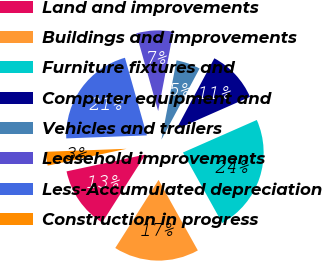Convert chart to OTSL. <chart><loc_0><loc_0><loc_500><loc_500><pie_chart><fcel>Land and improvements<fcel>Buildings and improvements<fcel>Furniture fixtures and<fcel>Computer equipment and<fcel>Vehicles and trailers<fcel>Leasehold improvements<fcel>Less-Accumulated depreciation<fcel>Construction in progress<nl><fcel>12.63%<fcel>17.11%<fcel>23.52%<fcel>10.55%<fcel>4.84%<fcel>7.39%<fcel>21.21%<fcel>2.76%<nl></chart> 